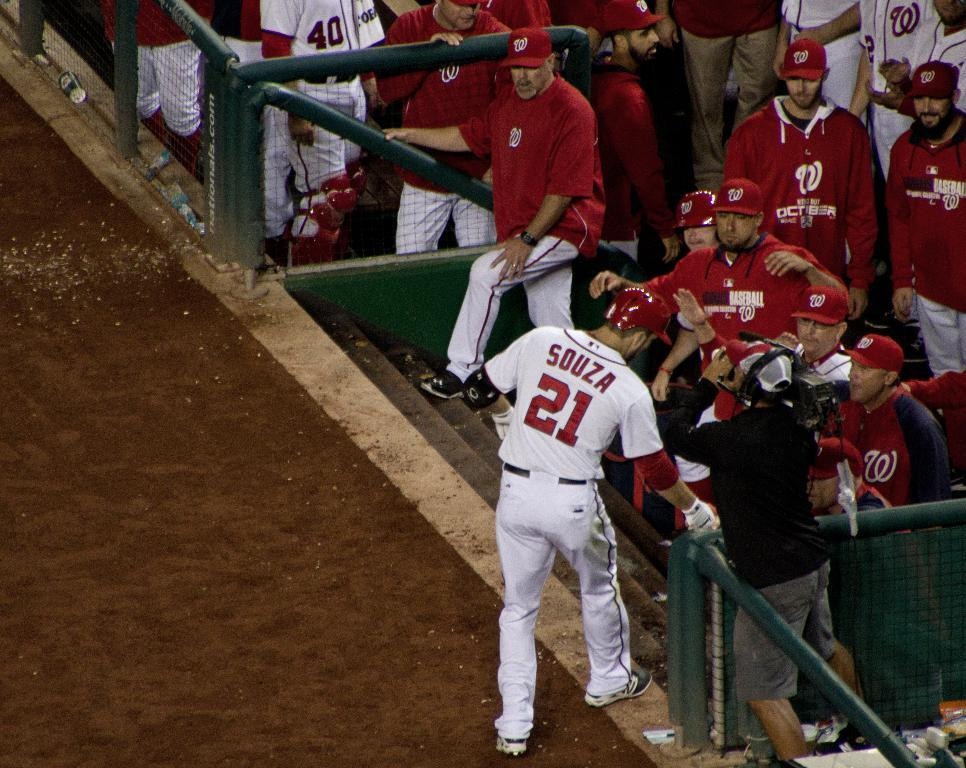<image>
Present a compact description of the photo's key features. A player who wears number 21, named Souza, heads into the dugout. 